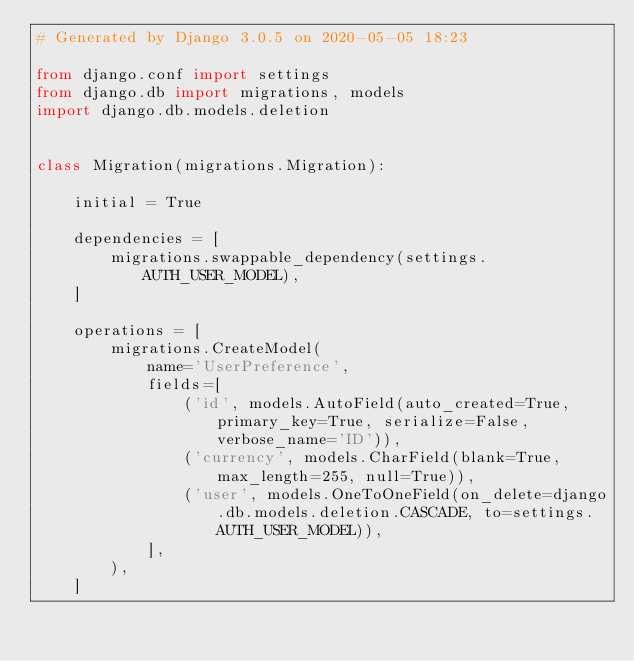Convert code to text. <code><loc_0><loc_0><loc_500><loc_500><_Python_># Generated by Django 3.0.5 on 2020-05-05 18:23

from django.conf import settings
from django.db import migrations, models
import django.db.models.deletion


class Migration(migrations.Migration):

    initial = True

    dependencies = [
        migrations.swappable_dependency(settings.AUTH_USER_MODEL),
    ]

    operations = [
        migrations.CreateModel(
            name='UserPreference',
            fields=[
                ('id', models.AutoField(auto_created=True, primary_key=True, serialize=False, verbose_name='ID')),
                ('currency', models.CharField(blank=True, max_length=255, null=True)),
                ('user', models.OneToOneField(on_delete=django.db.models.deletion.CASCADE, to=settings.AUTH_USER_MODEL)),
            ],
        ),
    ]
</code> 